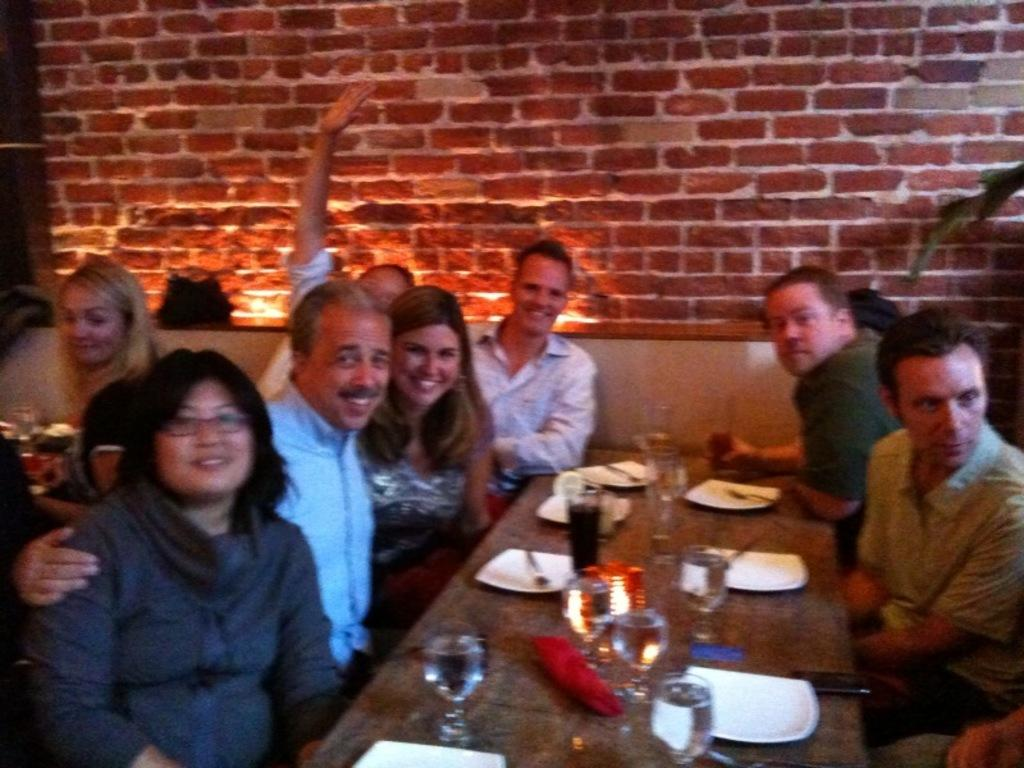What are the people in the image doing? The people in the image are sitting on a sofa. What can be seen on the table in the image? There is a glass, a plate, and a spoon on the table in the image. What is the background of the image? There is a back wall visible in the image. What type of scent can be detected coming from the apparatus in the image? There is no apparatus present in the image, so it is not possible to determine any scent. 